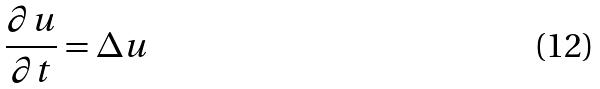<formula> <loc_0><loc_0><loc_500><loc_500>\frac { \partial u } { \partial t } = \Delta u</formula> 